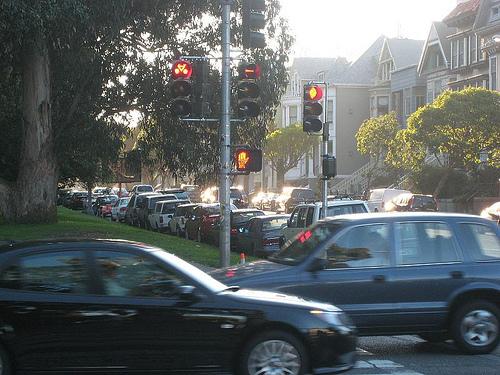What symbol is on the box telling you not to walk?
Answer briefly. Hand. Is anyone in the passenger seat?
Answer briefly. Yes. Is this a crowded street?
Answer briefly. Yes. Does the light say it is ok to walk?
Short answer required. No. Is there trees  around?
Quick response, please. Yes. What is the house in the background?
Write a very short answer. Townhouse. 